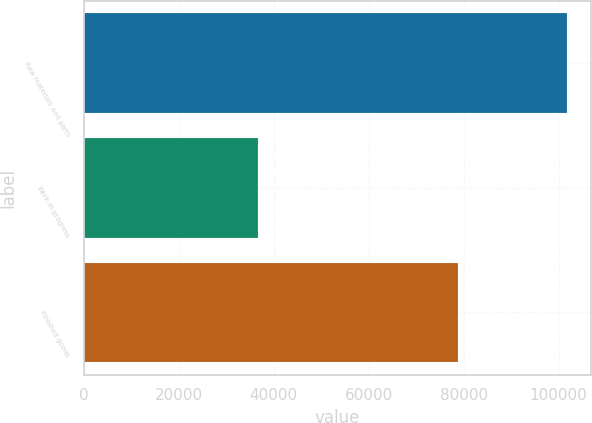Convert chart to OTSL. <chart><loc_0><loc_0><loc_500><loc_500><bar_chart><fcel>Raw materials and parts<fcel>Work-in-progress<fcel>Finished goods<nl><fcel>101660<fcel>36615<fcel>78829<nl></chart> 